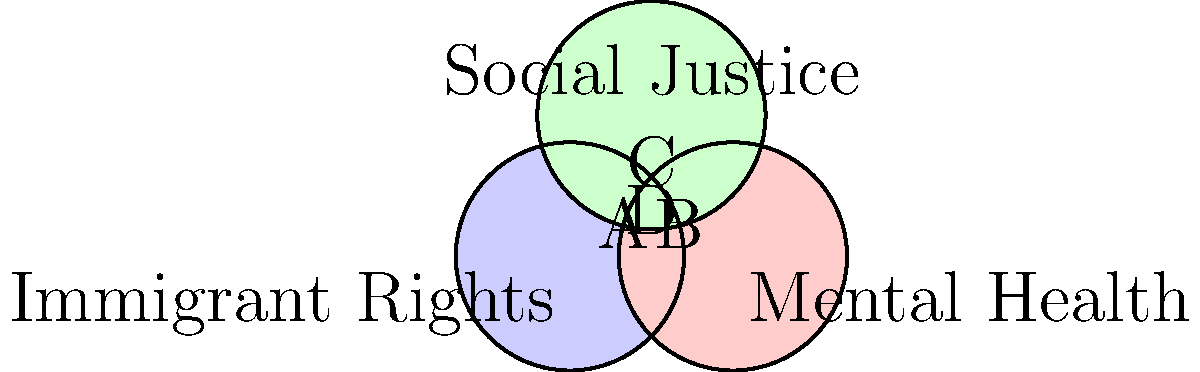In the Venn diagram above, areas A, B, C, and D represent intersections of different advocacy movements. Which area represents issues that involve all three: immigrant rights, mental health advocacy, and social justice movements? To answer this question, we need to understand what each circle and intersection represents:

1. The blue circle represents Immigrant Rights
2. The red circle represents Mental Health
3. The green circle represents Social Justice

Now, let's analyze each labeled area:

A: This area is the intersection of Immigrant Rights and Social Justice, but not Mental Health.
B: This area is the intersection of Mental Health and Social Justice, but not Immigrant Rights.
C: This area is the intersection of Immigrant Rights and Mental Health, but not Social Justice.
D: This central area is where all three circles overlap, representing the intersection of Immigrant Rights, Mental Health, and Social Justice.

Therefore, area D is the only region that represents issues involving all three movements.

This intersection highlights the complex, interconnected nature of these issues. For example:
- Immigrants often face unique mental health challenges due to trauma, displacement, and acculturation stress.
- Access to mental health care for immigrants is both a health care issue and a social justice issue.
- Advocating for immigrant rights often involves addressing systemic inequalities, which is a core aspect of social justice.
Answer: D 